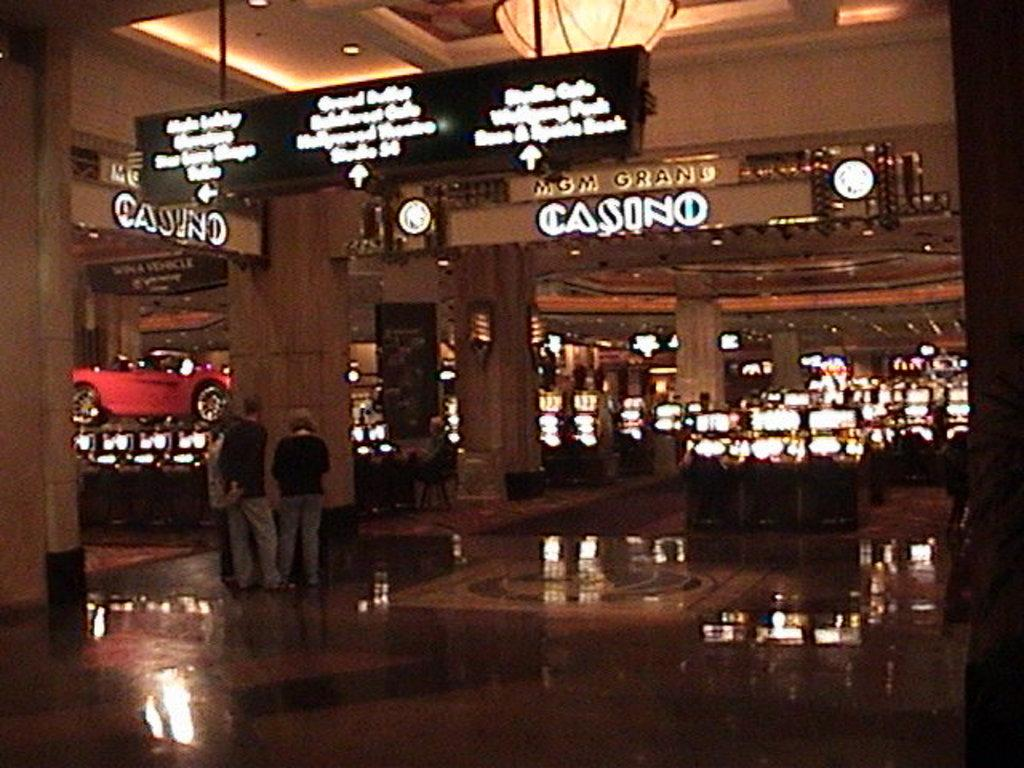What type of establishment is located in the center of the image? There is a casino store in the center of the image. Can you describe the people on the left side of the image? There are people standing on the left side of the image. Where is the lunchroom located in the image? There is no mention of a lunchroom in the image, so its location cannot be determined. 